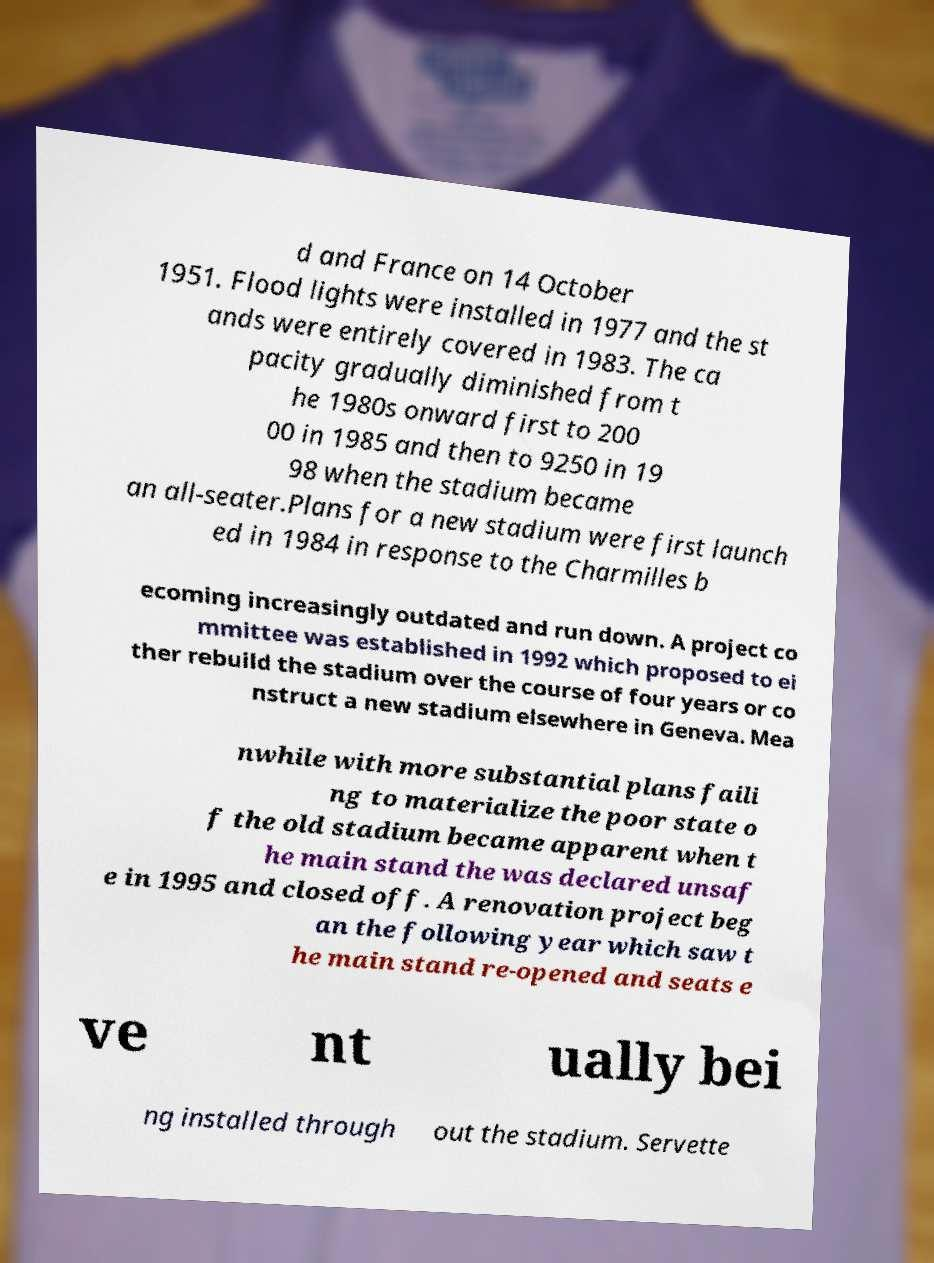Please read and relay the text visible in this image. What does it say? d and France on 14 October 1951. Flood lights were installed in 1977 and the st ands were entirely covered in 1983. The ca pacity gradually diminished from t he 1980s onward first to 200 00 in 1985 and then to 9250 in 19 98 when the stadium became an all-seater.Plans for a new stadium were first launch ed in 1984 in response to the Charmilles b ecoming increasingly outdated and run down. A project co mmittee was established in 1992 which proposed to ei ther rebuild the stadium over the course of four years or co nstruct a new stadium elsewhere in Geneva. Mea nwhile with more substantial plans faili ng to materialize the poor state o f the old stadium became apparent when t he main stand the was declared unsaf e in 1995 and closed off. A renovation project beg an the following year which saw t he main stand re-opened and seats e ve nt ually bei ng installed through out the stadium. Servette 